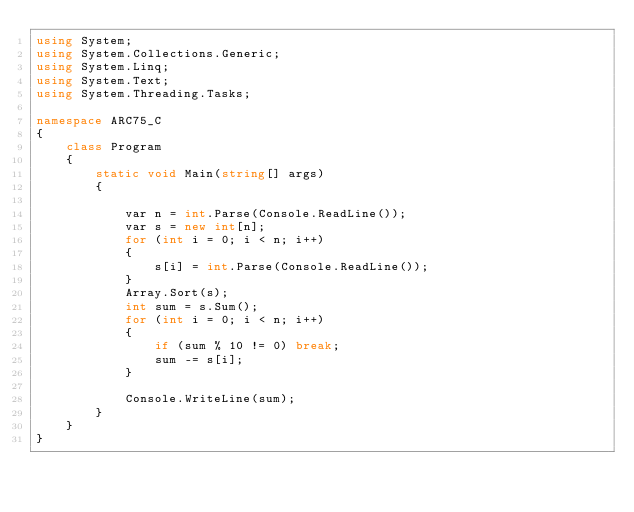Convert code to text. <code><loc_0><loc_0><loc_500><loc_500><_C#_>using System;
using System.Collections.Generic;
using System.Linq;
using System.Text;
using System.Threading.Tasks;

namespace ARC75_C
{
    class Program
    {
        static void Main(string[] args)
        {

            var n = int.Parse(Console.ReadLine());
            var s = new int[n];
            for (int i = 0; i < n; i++)
            {
                s[i] = int.Parse(Console.ReadLine());
            }
            Array.Sort(s);
            int sum = s.Sum();
            for (int i = 0; i < n; i++)
            {
                if (sum % 10 != 0) break;
                sum -= s[i];
            }

            Console.WriteLine(sum);
        }
    }
}
</code> 